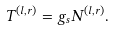Convert formula to latex. <formula><loc_0><loc_0><loc_500><loc_500>T ^ { ( l , r ) } = g _ { s } N ^ { ( l , r ) } .</formula> 